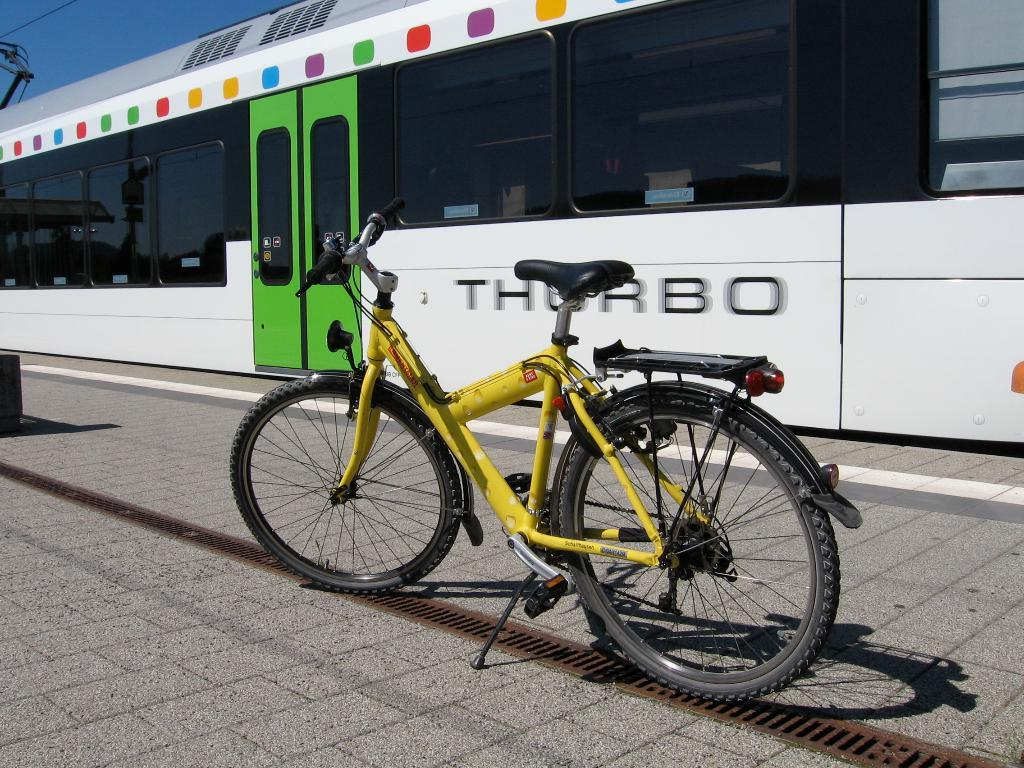What type of vehicle is on the track in the image? There is a locomotive on the track in the image. What other mode of transportation can be seen in the image? There is a bicycle on the floor in the image. What type of infrastructure is visible in the image? Electric cables are visible in the image. What is visible in the background of the image? The sky is visible in the image. What type of linen is draped over the locomotive in the image? There is no linen draped over the locomotive in the image; it is a vehicle on the track. 